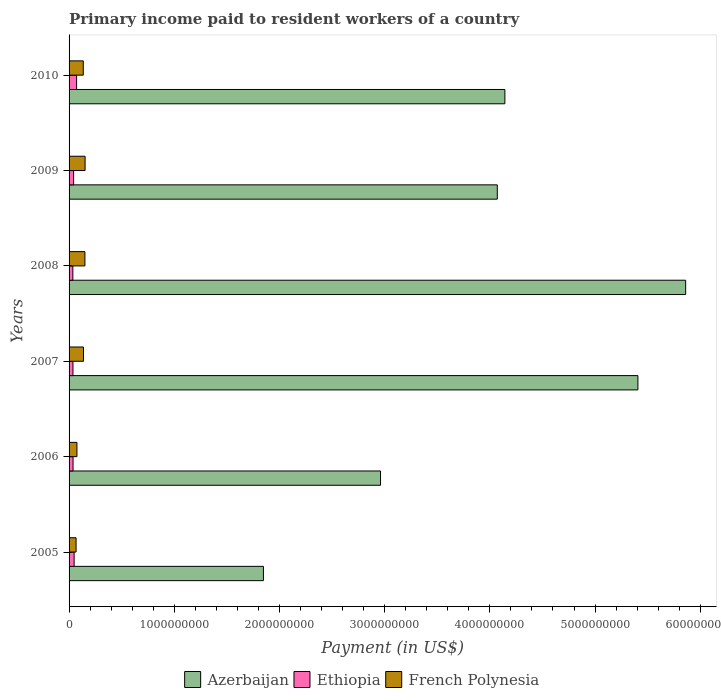Are the number of bars per tick equal to the number of legend labels?
Provide a short and direct response. Yes. How many bars are there on the 5th tick from the top?
Ensure brevity in your answer.  3. What is the label of the 2nd group of bars from the top?
Provide a short and direct response. 2009. In how many cases, is the number of bars for a given year not equal to the number of legend labels?
Your answer should be very brief. 0. What is the amount paid to workers in French Polynesia in 2010?
Give a very brief answer. 1.35e+08. Across all years, what is the maximum amount paid to workers in Ethiopia?
Ensure brevity in your answer.  7.17e+07. Across all years, what is the minimum amount paid to workers in Azerbaijan?
Offer a terse response. 1.85e+09. What is the total amount paid to workers in Azerbaijan in the graph?
Provide a short and direct response. 2.43e+1. What is the difference between the amount paid to workers in Ethiopia in 2006 and that in 2007?
Ensure brevity in your answer.  8.99e+05. What is the difference between the amount paid to workers in Ethiopia in 2009 and the amount paid to workers in Azerbaijan in 2007?
Provide a succinct answer. -5.36e+09. What is the average amount paid to workers in Ethiopia per year?
Make the answer very short. 4.56e+07. In the year 2005, what is the difference between the amount paid to workers in Ethiopia and amount paid to workers in Azerbaijan?
Your response must be concise. -1.80e+09. What is the ratio of the amount paid to workers in Azerbaijan in 2006 to that in 2009?
Offer a terse response. 0.73. Is the difference between the amount paid to workers in Ethiopia in 2008 and 2010 greater than the difference between the amount paid to workers in Azerbaijan in 2008 and 2010?
Keep it short and to the point. No. What is the difference between the highest and the second highest amount paid to workers in Azerbaijan?
Offer a terse response. 4.54e+08. What is the difference between the highest and the lowest amount paid to workers in French Polynesia?
Offer a terse response. 8.56e+07. What does the 2nd bar from the top in 2005 represents?
Offer a terse response. Ethiopia. What does the 1st bar from the bottom in 2010 represents?
Provide a short and direct response. Azerbaijan. Is it the case that in every year, the sum of the amount paid to workers in French Polynesia and amount paid to workers in Ethiopia is greater than the amount paid to workers in Azerbaijan?
Offer a terse response. No. How many bars are there?
Keep it short and to the point. 18. What is the difference between two consecutive major ticks on the X-axis?
Offer a terse response. 1.00e+09. Are the values on the major ticks of X-axis written in scientific E-notation?
Offer a very short reply. No. Does the graph contain any zero values?
Your answer should be compact. No. Where does the legend appear in the graph?
Ensure brevity in your answer.  Bottom center. How are the legend labels stacked?
Ensure brevity in your answer.  Horizontal. What is the title of the graph?
Your answer should be very brief. Primary income paid to resident workers of a country. Does "Iraq" appear as one of the legend labels in the graph?
Your response must be concise. No. What is the label or title of the X-axis?
Your response must be concise. Payment (in US$). What is the Payment (in US$) in Azerbaijan in 2005?
Ensure brevity in your answer.  1.85e+09. What is the Payment (in US$) in Ethiopia in 2005?
Your answer should be very brief. 4.80e+07. What is the Payment (in US$) of French Polynesia in 2005?
Keep it short and to the point. 6.66e+07. What is the Payment (in US$) of Azerbaijan in 2006?
Keep it short and to the point. 2.96e+09. What is the Payment (in US$) in Ethiopia in 2006?
Provide a succinct answer. 3.78e+07. What is the Payment (in US$) of French Polynesia in 2006?
Offer a very short reply. 7.47e+07. What is the Payment (in US$) of Azerbaijan in 2007?
Provide a short and direct response. 5.41e+09. What is the Payment (in US$) in Ethiopia in 2007?
Provide a succinct answer. 3.69e+07. What is the Payment (in US$) of French Polynesia in 2007?
Your answer should be very brief. 1.37e+08. What is the Payment (in US$) of Azerbaijan in 2008?
Keep it short and to the point. 5.86e+09. What is the Payment (in US$) in Ethiopia in 2008?
Keep it short and to the point. 3.59e+07. What is the Payment (in US$) of French Polynesia in 2008?
Keep it short and to the point. 1.50e+08. What is the Payment (in US$) in Azerbaijan in 2009?
Keep it short and to the point. 4.07e+09. What is the Payment (in US$) of Ethiopia in 2009?
Keep it short and to the point. 4.33e+07. What is the Payment (in US$) in French Polynesia in 2009?
Offer a very short reply. 1.52e+08. What is the Payment (in US$) of Azerbaijan in 2010?
Your answer should be very brief. 4.14e+09. What is the Payment (in US$) of Ethiopia in 2010?
Your response must be concise. 7.17e+07. What is the Payment (in US$) of French Polynesia in 2010?
Ensure brevity in your answer.  1.35e+08. Across all years, what is the maximum Payment (in US$) in Azerbaijan?
Offer a very short reply. 5.86e+09. Across all years, what is the maximum Payment (in US$) of Ethiopia?
Ensure brevity in your answer.  7.17e+07. Across all years, what is the maximum Payment (in US$) in French Polynesia?
Your answer should be compact. 1.52e+08. Across all years, what is the minimum Payment (in US$) of Azerbaijan?
Make the answer very short. 1.85e+09. Across all years, what is the minimum Payment (in US$) in Ethiopia?
Give a very brief answer. 3.59e+07. Across all years, what is the minimum Payment (in US$) in French Polynesia?
Ensure brevity in your answer.  6.66e+07. What is the total Payment (in US$) in Azerbaijan in the graph?
Make the answer very short. 2.43e+1. What is the total Payment (in US$) in Ethiopia in the graph?
Offer a very short reply. 2.74e+08. What is the total Payment (in US$) of French Polynesia in the graph?
Your answer should be very brief. 7.16e+08. What is the difference between the Payment (in US$) of Azerbaijan in 2005 and that in 2006?
Give a very brief answer. -1.11e+09. What is the difference between the Payment (in US$) of Ethiopia in 2005 and that in 2006?
Your response must be concise. 1.02e+07. What is the difference between the Payment (in US$) in French Polynesia in 2005 and that in 2006?
Offer a very short reply. -8.10e+06. What is the difference between the Payment (in US$) of Azerbaijan in 2005 and that in 2007?
Keep it short and to the point. -3.56e+09. What is the difference between the Payment (in US$) in Ethiopia in 2005 and that in 2007?
Give a very brief answer. 1.11e+07. What is the difference between the Payment (in US$) in French Polynesia in 2005 and that in 2007?
Your response must be concise. -7.04e+07. What is the difference between the Payment (in US$) in Azerbaijan in 2005 and that in 2008?
Your answer should be very brief. -4.01e+09. What is the difference between the Payment (in US$) of Ethiopia in 2005 and that in 2008?
Give a very brief answer. 1.22e+07. What is the difference between the Payment (in US$) in French Polynesia in 2005 and that in 2008?
Your answer should be very brief. -8.38e+07. What is the difference between the Payment (in US$) of Azerbaijan in 2005 and that in 2009?
Your response must be concise. -2.22e+09. What is the difference between the Payment (in US$) in Ethiopia in 2005 and that in 2009?
Your answer should be very brief. 4.74e+06. What is the difference between the Payment (in US$) in French Polynesia in 2005 and that in 2009?
Offer a very short reply. -8.56e+07. What is the difference between the Payment (in US$) of Azerbaijan in 2005 and that in 2010?
Ensure brevity in your answer.  -2.30e+09. What is the difference between the Payment (in US$) of Ethiopia in 2005 and that in 2010?
Offer a terse response. -2.36e+07. What is the difference between the Payment (in US$) of French Polynesia in 2005 and that in 2010?
Provide a succinct answer. -6.84e+07. What is the difference between the Payment (in US$) in Azerbaijan in 2006 and that in 2007?
Offer a terse response. -2.45e+09. What is the difference between the Payment (in US$) in Ethiopia in 2006 and that in 2007?
Your response must be concise. 8.99e+05. What is the difference between the Payment (in US$) of French Polynesia in 2006 and that in 2007?
Ensure brevity in your answer.  -6.23e+07. What is the difference between the Payment (in US$) in Azerbaijan in 2006 and that in 2008?
Make the answer very short. -2.90e+09. What is the difference between the Payment (in US$) of Ethiopia in 2006 and that in 2008?
Keep it short and to the point. 1.96e+06. What is the difference between the Payment (in US$) in French Polynesia in 2006 and that in 2008?
Give a very brief answer. -7.57e+07. What is the difference between the Payment (in US$) in Azerbaijan in 2006 and that in 2009?
Provide a succinct answer. -1.11e+09. What is the difference between the Payment (in US$) of Ethiopia in 2006 and that in 2009?
Give a very brief answer. -5.47e+06. What is the difference between the Payment (in US$) in French Polynesia in 2006 and that in 2009?
Your response must be concise. -7.75e+07. What is the difference between the Payment (in US$) in Azerbaijan in 2006 and that in 2010?
Your answer should be very brief. -1.18e+09. What is the difference between the Payment (in US$) of Ethiopia in 2006 and that in 2010?
Offer a terse response. -3.38e+07. What is the difference between the Payment (in US$) of French Polynesia in 2006 and that in 2010?
Offer a terse response. -6.03e+07. What is the difference between the Payment (in US$) of Azerbaijan in 2007 and that in 2008?
Give a very brief answer. -4.54e+08. What is the difference between the Payment (in US$) of Ethiopia in 2007 and that in 2008?
Keep it short and to the point. 1.06e+06. What is the difference between the Payment (in US$) in French Polynesia in 2007 and that in 2008?
Offer a very short reply. -1.34e+07. What is the difference between the Payment (in US$) in Azerbaijan in 2007 and that in 2009?
Make the answer very short. 1.34e+09. What is the difference between the Payment (in US$) in Ethiopia in 2007 and that in 2009?
Provide a short and direct response. -6.36e+06. What is the difference between the Payment (in US$) of French Polynesia in 2007 and that in 2009?
Ensure brevity in your answer.  -1.52e+07. What is the difference between the Payment (in US$) in Azerbaijan in 2007 and that in 2010?
Offer a very short reply. 1.26e+09. What is the difference between the Payment (in US$) in Ethiopia in 2007 and that in 2010?
Your answer should be very brief. -3.47e+07. What is the difference between the Payment (in US$) in French Polynesia in 2007 and that in 2010?
Your answer should be compact. 2.00e+06. What is the difference between the Payment (in US$) in Azerbaijan in 2008 and that in 2009?
Provide a succinct answer. 1.79e+09. What is the difference between the Payment (in US$) in Ethiopia in 2008 and that in 2009?
Your answer should be compact. -7.43e+06. What is the difference between the Payment (in US$) in French Polynesia in 2008 and that in 2009?
Keep it short and to the point. -1.75e+06. What is the difference between the Payment (in US$) of Azerbaijan in 2008 and that in 2010?
Give a very brief answer. 1.72e+09. What is the difference between the Payment (in US$) in Ethiopia in 2008 and that in 2010?
Provide a short and direct response. -3.58e+07. What is the difference between the Payment (in US$) of French Polynesia in 2008 and that in 2010?
Your response must be concise. 1.54e+07. What is the difference between the Payment (in US$) in Azerbaijan in 2009 and that in 2010?
Provide a succinct answer. -7.20e+07. What is the difference between the Payment (in US$) of Ethiopia in 2009 and that in 2010?
Your answer should be compact. -2.84e+07. What is the difference between the Payment (in US$) of French Polynesia in 2009 and that in 2010?
Provide a succinct answer. 1.72e+07. What is the difference between the Payment (in US$) in Azerbaijan in 2005 and the Payment (in US$) in Ethiopia in 2006?
Give a very brief answer. 1.81e+09. What is the difference between the Payment (in US$) of Azerbaijan in 2005 and the Payment (in US$) of French Polynesia in 2006?
Offer a very short reply. 1.77e+09. What is the difference between the Payment (in US$) of Ethiopia in 2005 and the Payment (in US$) of French Polynesia in 2006?
Give a very brief answer. -2.67e+07. What is the difference between the Payment (in US$) of Azerbaijan in 2005 and the Payment (in US$) of Ethiopia in 2007?
Make the answer very short. 1.81e+09. What is the difference between the Payment (in US$) in Azerbaijan in 2005 and the Payment (in US$) in French Polynesia in 2007?
Your answer should be very brief. 1.71e+09. What is the difference between the Payment (in US$) in Ethiopia in 2005 and the Payment (in US$) in French Polynesia in 2007?
Offer a terse response. -8.90e+07. What is the difference between the Payment (in US$) in Azerbaijan in 2005 and the Payment (in US$) in Ethiopia in 2008?
Provide a succinct answer. 1.81e+09. What is the difference between the Payment (in US$) of Azerbaijan in 2005 and the Payment (in US$) of French Polynesia in 2008?
Your answer should be very brief. 1.70e+09. What is the difference between the Payment (in US$) in Ethiopia in 2005 and the Payment (in US$) in French Polynesia in 2008?
Make the answer very short. -1.02e+08. What is the difference between the Payment (in US$) in Azerbaijan in 2005 and the Payment (in US$) in Ethiopia in 2009?
Make the answer very short. 1.80e+09. What is the difference between the Payment (in US$) in Azerbaijan in 2005 and the Payment (in US$) in French Polynesia in 2009?
Make the answer very short. 1.70e+09. What is the difference between the Payment (in US$) in Ethiopia in 2005 and the Payment (in US$) in French Polynesia in 2009?
Your answer should be compact. -1.04e+08. What is the difference between the Payment (in US$) of Azerbaijan in 2005 and the Payment (in US$) of Ethiopia in 2010?
Give a very brief answer. 1.78e+09. What is the difference between the Payment (in US$) of Azerbaijan in 2005 and the Payment (in US$) of French Polynesia in 2010?
Ensure brevity in your answer.  1.71e+09. What is the difference between the Payment (in US$) in Ethiopia in 2005 and the Payment (in US$) in French Polynesia in 2010?
Provide a short and direct response. -8.70e+07. What is the difference between the Payment (in US$) of Azerbaijan in 2006 and the Payment (in US$) of Ethiopia in 2007?
Provide a short and direct response. 2.92e+09. What is the difference between the Payment (in US$) of Azerbaijan in 2006 and the Payment (in US$) of French Polynesia in 2007?
Offer a very short reply. 2.82e+09. What is the difference between the Payment (in US$) of Ethiopia in 2006 and the Payment (in US$) of French Polynesia in 2007?
Keep it short and to the point. -9.92e+07. What is the difference between the Payment (in US$) in Azerbaijan in 2006 and the Payment (in US$) in Ethiopia in 2008?
Your answer should be very brief. 2.92e+09. What is the difference between the Payment (in US$) of Azerbaijan in 2006 and the Payment (in US$) of French Polynesia in 2008?
Your answer should be very brief. 2.81e+09. What is the difference between the Payment (in US$) in Ethiopia in 2006 and the Payment (in US$) in French Polynesia in 2008?
Provide a succinct answer. -1.13e+08. What is the difference between the Payment (in US$) of Azerbaijan in 2006 and the Payment (in US$) of Ethiopia in 2009?
Your answer should be compact. 2.92e+09. What is the difference between the Payment (in US$) of Azerbaijan in 2006 and the Payment (in US$) of French Polynesia in 2009?
Make the answer very short. 2.81e+09. What is the difference between the Payment (in US$) of Ethiopia in 2006 and the Payment (in US$) of French Polynesia in 2009?
Give a very brief answer. -1.14e+08. What is the difference between the Payment (in US$) in Azerbaijan in 2006 and the Payment (in US$) in Ethiopia in 2010?
Make the answer very short. 2.89e+09. What is the difference between the Payment (in US$) in Azerbaijan in 2006 and the Payment (in US$) in French Polynesia in 2010?
Ensure brevity in your answer.  2.83e+09. What is the difference between the Payment (in US$) in Ethiopia in 2006 and the Payment (in US$) in French Polynesia in 2010?
Offer a terse response. -9.72e+07. What is the difference between the Payment (in US$) of Azerbaijan in 2007 and the Payment (in US$) of Ethiopia in 2008?
Keep it short and to the point. 5.37e+09. What is the difference between the Payment (in US$) in Azerbaijan in 2007 and the Payment (in US$) in French Polynesia in 2008?
Provide a short and direct response. 5.26e+09. What is the difference between the Payment (in US$) in Ethiopia in 2007 and the Payment (in US$) in French Polynesia in 2008?
Provide a short and direct response. -1.14e+08. What is the difference between the Payment (in US$) of Azerbaijan in 2007 and the Payment (in US$) of Ethiopia in 2009?
Your answer should be very brief. 5.36e+09. What is the difference between the Payment (in US$) in Azerbaijan in 2007 and the Payment (in US$) in French Polynesia in 2009?
Make the answer very short. 5.25e+09. What is the difference between the Payment (in US$) in Ethiopia in 2007 and the Payment (in US$) in French Polynesia in 2009?
Provide a succinct answer. -1.15e+08. What is the difference between the Payment (in US$) in Azerbaijan in 2007 and the Payment (in US$) in Ethiopia in 2010?
Offer a very short reply. 5.34e+09. What is the difference between the Payment (in US$) of Azerbaijan in 2007 and the Payment (in US$) of French Polynesia in 2010?
Your answer should be compact. 5.27e+09. What is the difference between the Payment (in US$) of Ethiopia in 2007 and the Payment (in US$) of French Polynesia in 2010?
Offer a very short reply. -9.81e+07. What is the difference between the Payment (in US$) in Azerbaijan in 2008 and the Payment (in US$) in Ethiopia in 2009?
Offer a very short reply. 5.82e+09. What is the difference between the Payment (in US$) of Azerbaijan in 2008 and the Payment (in US$) of French Polynesia in 2009?
Your response must be concise. 5.71e+09. What is the difference between the Payment (in US$) of Ethiopia in 2008 and the Payment (in US$) of French Polynesia in 2009?
Offer a terse response. -1.16e+08. What is the difference between the Payment (in US$) of Azerbaijan in 2008 and the Payment (in US$) of Ethiopia in 2010?
Offer a terse response. 5.79e+09. What is the difference between the Payment (in US$) in Azerbaijan in 2008 and the Payment (in US$) in French Polynesia in 2010?
Provide a succinct answer. 5.73e+09. What is the difference between the Payment (in US$) of Ethiopia in 2008 and the Payment (in US$) of French Polynesia in 2010?
Your answer should be compact. -9.92e+07. What is the difference between the Payment (in US$) in Azerbaijan in 2009 and the Payment (in US$) in Ethiopia in 2010?
Keep it short and to the point. 4.00e+09. What is the difference between the Payment (in US$) of Azerbaijan in 2009 and the Payment (in US$) of French Polynesia in 2010?
Ensure brevity in your answer.  3.94e+09. What is the difference between the Payment (in US$) in Ethiopia in 2009 and the Payment (in US$) in French Polynesia in 2010?
Your answer should be compact. -9.17e+07. What is the average Payment (in US$) in Azerbaijan per year?
Offer a terse response. 4.05e+09. What is the average Payment (in US$) in Ethiopia per year?
Provide a succinct answer. 4.56e+07. What is the average Payment (in US$) in French Polynesia per year?
Your response must be concise. 1.19e+08. In the year 2005, what is the difference between the Payment (in US$) of Azerbaijan and Payment (in US$) of Ethiopia?
Keep it short and to the point. 1.80e+09. In the year 2005, what is the difference between the Payment (in US$) of Azerbaijan and Payment (in US$) of French Polynesia?
Offer a terse response. 1.78e+09. In the year 2005, what is the difference between the Payment (in US$) of Ethiopia and Payment (in US$) of French Polynesia?
Provide a short and direct response. -1.86e+07. In the year 2006, what is the difference between the Payment (in US$) of Azerbaijan and Payment (in US$) of Ethiopia?
Make the answer very short. 2.92e+09. In the year 2006, what is the difference between the Payment (in US$) in Azerbaijan and Payment (in US$) in French Polynesia?
Make the answer very short. 2.89e+09. In the year 2006, what is the difference between the Payment (in US$) in Ethiopia and Payment (in US$) in French Polynesia?
Make the answer very short. -3.69e+07. In the year 2007, what is the difference between the Payment (in US$) in Azerbaijan and Payment (in US$) in Ethiopia?
Keep it short and to the point. 5.37e+09. In the year 2007, what is the difference between the Payment (in US$) in Azerbaijan and Payment (in US$) in French Polynesia?
Keep it short and to the point. 5.27e+09. In the year 2007, what is the difference between the Payment (in US$) of Ethiopia and Payment (in US$) of French Polynesia?
Your answer should be very brief. -1.00e+08. In the year 2008, what is the difference between the Payment (in US$) in Azerbaijan and Payment (in US$) in Ethiopia?
Your answer should be compact. 5.83e+09. In the year 2008, what is the difference between the Payment (in US$) of Azerbaijan and Payment (in US$) of French Polynesia?
Offer a very short reply. 5.71e+09. In the year 2008, what is the difference between the Payment (in US$) of Ethiopia and Payment (in US$) of French Polynesia?
Provide a short and direct response. -1.15e+08. In the year 2009, what is the difference between the Payment (in US$) of Azerbaijan and Payment (in US$) of Ethiopia?
Ensure brevity in your answer.  4.03e+09. In the year 2009, what is the difference between the Payment (in US$) in Azerbaijan and Payment (in US$) in French Polynesia?
Provide a succinct answer. 3.92e+09. In the year 2009, what is the difference between the Payment (in US$) in Ethiopia and Payment (in US$) in French Polynesia?
Offer a very short reply. -1.09e+08. In the year 2010, what is the difference between the Payment (in US$) of Azerbaijan and Payment (in US$) of Ethiopia?
Keep it short and to the point. 4.07e+09. In the year 2010, what is the difference between the Payment (in US$) of Azerbaijan and Payment (in US$) of French Polynesia?
Give a very brief answer. 4.01e+09. In the year 2010, what is the difference between the Payment (in US$) in Ethiopia and Payment (in US$) in French Polynesia?
Offer a very short reply. -6.34e+07. What is the ratio of the Payment (in US$) in Azerbaijan in 2005 to that in 2006?
Keep it short and to the point. 0.62. What is the ratio of the Payment (in US$) in Ethiopia in 2005 to that in 2006?
Make the answer very short. 1.27. What is the ratio of the Payment (in US$) in French Polynesia in 2005 to that in 2006?
Make the answer very short. 0.89. What is the ratio of the Payment (in US$) in Azerbaijan in 2005 to that in 2007?
Keep it short and to the point. 0.34. What is the ratio of the Payment (in US$) in Ethiopia in 2005 to that in 2007?
Your answer should be compact. 1.3. What is the ratio of the Payment (in US$) in French Polynesia in 2005 to that in 2007?
Offer a terse response. 0.49. What is the ratio of the Payment (in US$) of Azerbaijan in 2005 to that in 2008?
Make the answer very short. 0.32. What is the ratio of the Payment (in US$) in Ethiopia in 2005 to that in 2008?
Your answer should be very brief. 1.34. What is the ratio of the Payment (in US$) of French Polynesia in 2005 to that in 2008?
Your answer should be compact. 0.44. What is the ratio of the Payment (in US$) in Azerbaijan in 2005 to that in 2009?
Your answer should be very brief. 0.45. What is the ratio of the Payment (in US$) of Ethiopia in 2005 to that in 2009?
Your response must be concise. 1.11. What is the ratio of the Payment (in US$) of French Polynesia in 2005 to that in 2009?
Give a very brief answer. 0.44. What is the ratio of the Payment (in US$) in Azerbaijan in 2005 to that in 2010?
Give a very brief answer. 0.45. What is the ratio of the Payment (in US$) of Ethiopia in 2005 to that in 2010?
Offer a terse response. 0.67. What is the ratio of the Payment (in US$) in French Polynesia in 2005 to that in 2010?
Keep it short and to the point. 0.49. What is the ratio of the Payment (in US$) of Azerbaijan in 2006 to that in 2007?
Make the answer very short. 0.55. What is the ratio of the Payment (in US$) of Ethiopia in 2006 to that in 2007?
Keep it short and to the point. 1.02. What is the ratio of the Payment (in US$) of French Polynesia in 2006 to that in 2007?
Give a very brief answer. 0.55. What is the ratio of the Payment (in US$) of Azerbaijan in 2006 to that in 2008?
Keep it short and to the point. 0.51. What is the ratio of the Payment (in US$) of Ethiopia in 2006 to that in 2008?
Your response must be concise. 1.05. What is the ratio of the Payment (in US$) in French Polynesia in 2006 to that in 2008?
Give a very brief answer. 0.5. What is the ratio of the Payment (in US$) in Azerbaijan in 2006 to that in 2009?
Provide a short and direct response. 0.73. What is the ratio of the Payment (in US$) in Ethiopia in 2006 to that in 2009?
Provide a succinct answer. 0.87. What is the ratio of the Payment (in US$) of French Polynesia in 2006 to that in 2009?
Provide a succinct answer. 0.49. What is the ratio of the Payment (in US$) in Azerbaijan in 2006 to that in 2010?
Keep it short and to the point. 0.71. What is the ratio of the Payment (in US$) of Ethiopia in 2006 to that in 2010?
Your response must be concise. 0.53. What is the ratio of the Payment (in US$) in French Polynesia in 2006 to that in 2010?
Your answer should be very brief. 0.55. What is the ratio of the Payment (in US$) of Azerbaijan in 2007 to that in 2008?
Your answer should be compact. 0.92. What is the ratio of the Payment (in US$) in Ethiopia in 2007 to that in 2008?
Your answer should be compact. 1.03. What is the ratio of the Payment (in US$) of French Polynesia in 2007 to that in 2008?
Make the answer very short. 0.91. What is the ratio of the Payment (in US$) of Azerbaijan in 2007 to that in 2009?
Provide a short and direct response. 1.33. What is the ratio of the Payment (in US$) of Ethiopia in 2007 to that in 2009?
Your answer should be compact. 0.85. What is the ratio of the Payment (in US$) in French Polynesia in 2007 to that in 2009?
Your response must be concise. 0.9. What is the ratio of the Payment (in US$) in Azerbaijan in 2007 to that in 2010?
Provide a short and direct response. 1.31. What is the ratio of the Payment (in US$) in Ethiopia in 2007 to that in 2010?
Your answer should be very brief. 0.52. What is the ratio of the Payment (in US$) in French Polynesia in 2007 to that in 2010?
Make the answer very short. 1.01. What is the ratio of the Payment (in US$) in Azerbaijan in 2008 to that in 2009?
Your answer should be compact. 1.44. What is the ratio of the Payment (in US$) of Ethiopia in 2008 to that in 2009?
Make the answer very short. 0.83. What is the ratio of the Payment (in US$) in French Polynesia in 2008 to that in 2009?
Make the answer very short. 0.99. What is the ratio of the Payment (in US$) in Azerbaijan in 2008 to that in 2010?
Provide a succinct answer. 1.41. What is the ratio of the Payment (in US$) of Ethiopia in 2008 to that in 2010?
Offer a very short reply. 0.5. What is the ratio of the Payment (in US$) in French Polynesia in 2008 to that in 2010?
Offer a very short reply. 1.11. What is the ratio of the Payment (in US$) of Azerbaijan in 2009 to that in 2010?
Provide a short and direct response. 0.98. What is the ratio of the Payment (in US$) of Ethiopia in 2009 to that in 2010?
Make the answer very short. 0.6. What is the ratio of the Payment (in US$) of French Polynesia in 2009 to that in 2010?
Your answer should be compact. 1.13. What is the difference between the highest and the second highest Payment (in US$) of Azerbaijan?
Your response must be concise. 4.54e+08. What is the difference between the highest and the second highest Payment (in US$) in Ethiopia?
Your response must be concise. 2.36e+07. What is the difference between the highest and the second highest Payment (in US$) of French Polynesia?
Offer a very short reply. 1.75e+06. What is the difference between the highest and the lowest Payment (in US$) of Azerbaijan?
Keep it short and to the point. 4.01e+09. What is the difference between the highest and the lowest Payment (in US$) in Ethiopia?
Offer a terse response. 3.58e+07. What is the difference between the highest and the lowest Payment (in US$) of French Polynesia?
Your answer should be very brief. 8.56e+07. 